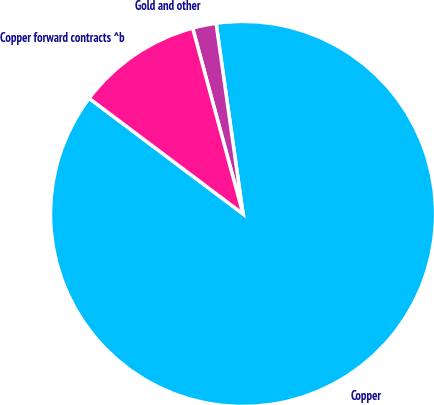Convert chart. <chart><loc_0><loc_0><loc_500><loc_500><pie_chart><fcel>Copper<fcel>Gold and other<fcel>Copper forward contracts ^b<nl><fcel>87.5%<fcel>1.98%<fcel>10.53%<nl></chart> 